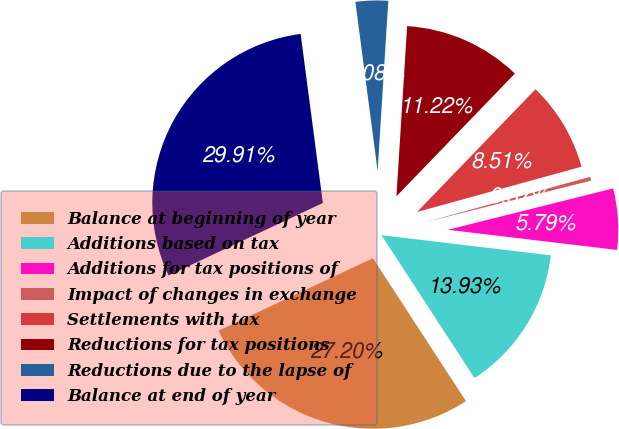Convert chart to OTSL. <chart><loc_0><loc_0><loc_500><loc_500><pie_chart><fcel>Balance at beginning of year<fcel>Additions based on tax<fcel>Additions for tax positions of<fcel>Impact of changes in exchange<fcel>Settlements with tax<fcel>Reductions for tax positions<fcel>Reductions due to the lapse of<fcel>Balance at end of year<nl><fcel>27.2%<fcel>13.93%<fcel>5.79%<fcel>0.37%<fcel>8.51%<fcel>11.22%<fcel>3.08%<fcel>29.91%<nl></chart> 